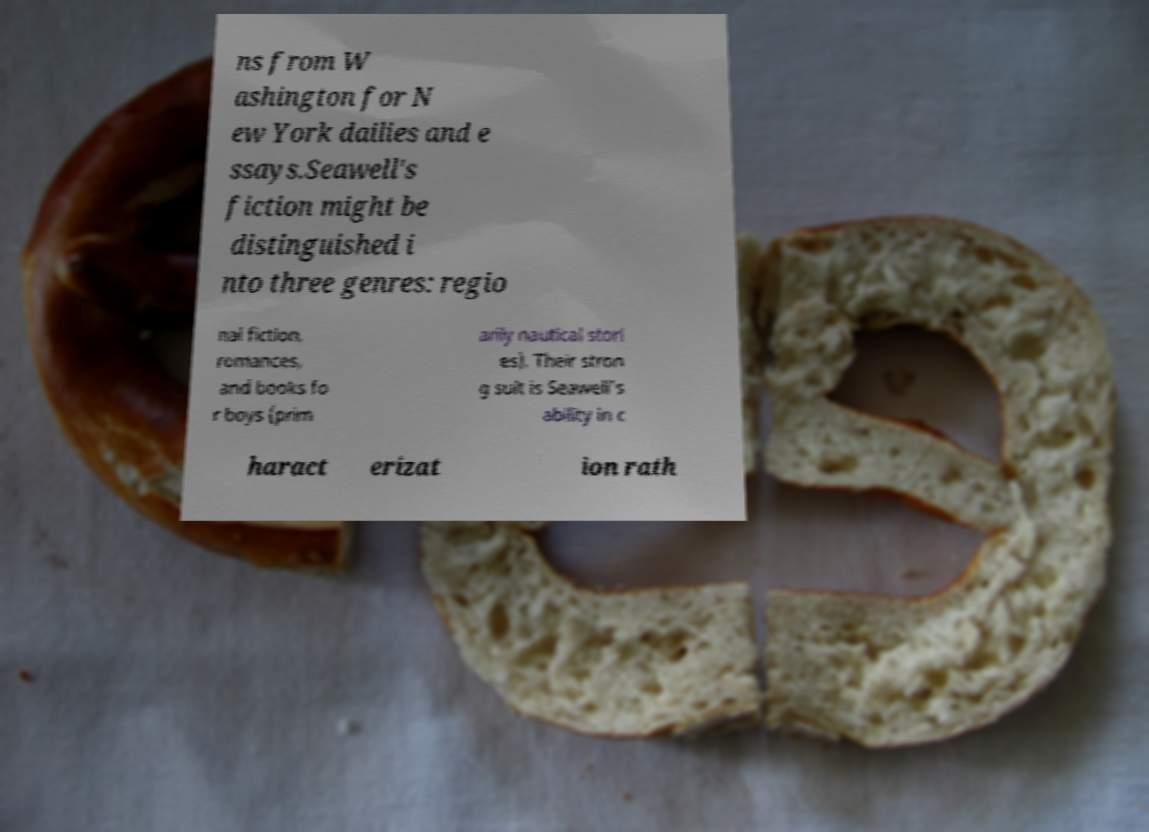Could you extract and type out the text from this image? ns from W ashington for N ew York dailies and e ssays.Seawell's fiction might be distinguished i nto three genres: regio nal fiction, romances, and books fo r boys (prim arily nautical stori es). Their stron g suit is Seawell's ability in c haract erizat ion rath 